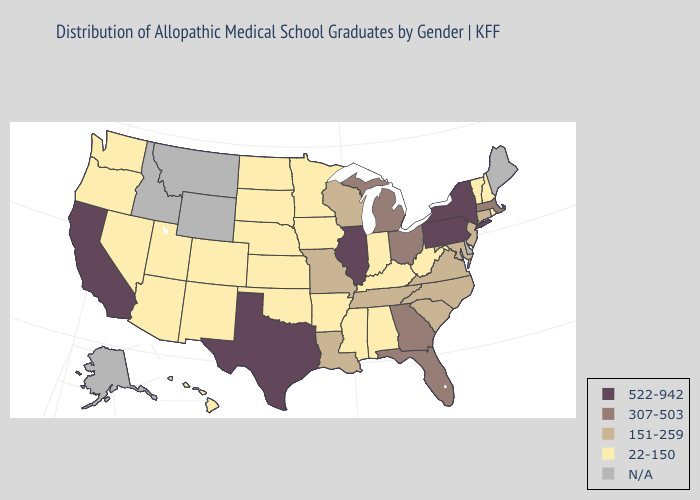What is the lowest value in the MidWest?
Be succinct. 22-150. Does Texas have the lowest value in the USA?
Keep it brief. No. What is the lowest value in the USA?
Concise answer only. 22-150. What is the highest value in the Northeast ?
Quick response, please. 522-942. Which states have the lowest value in the MidWest?
Give a very brief answer. Indiana, Iowa, Kansas, Minnesota, Nebraska, North Dakota, South Dakota. Which states have the highest value in the USA?
Concise answer only. California, Illinois, New York, Pennsylvania, Texas. Name the states that have a value in the range 307-503?
Answer briefly. Florida, Georgia, Massachusetts, Michigan, Ohio. Which states have the lowest value in the Northeast?
Short answer required. New Hampshire, Rhode Island, Vermont. Which states have the lowest value in the USA?
Answer briefly. Alabama, Arizona, Arkansas, Colorado, Hawaii, Indiana, Iowa, Kansas, Kentucky, Minnesota, Mississippi, Nebraska, Nevada, New Hampshire, New Mexico, North Dakota, Oklahoma, Oregon, Rhode Island, South Dakota, Utah, Vermont, Washington, West Virginia. Which states hav the highest value in the West?
Keep it brief. California. What is the value of Georgia?
Short answer required. 307-503. Which states hav the highest value in the Northeast?
Short answer required. New York, Pennsylvania. Among the states that border Oregon , does Washington have the lowest value?
Answer briefly. Yes. 